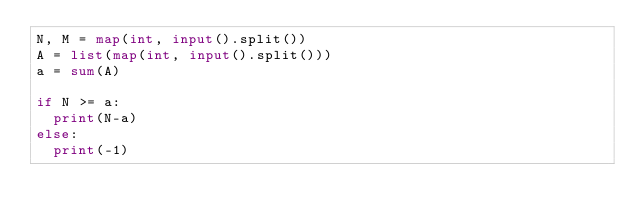Convert code to text. <code><loc_0><loc_0><loc_500><loc_500><_Python_>N, M = map(int, input().split())
A = list(map(int, input().split()))
a = sum(A)

if N >= a:
  print(N-a)
else:
  print(-1)</code> 